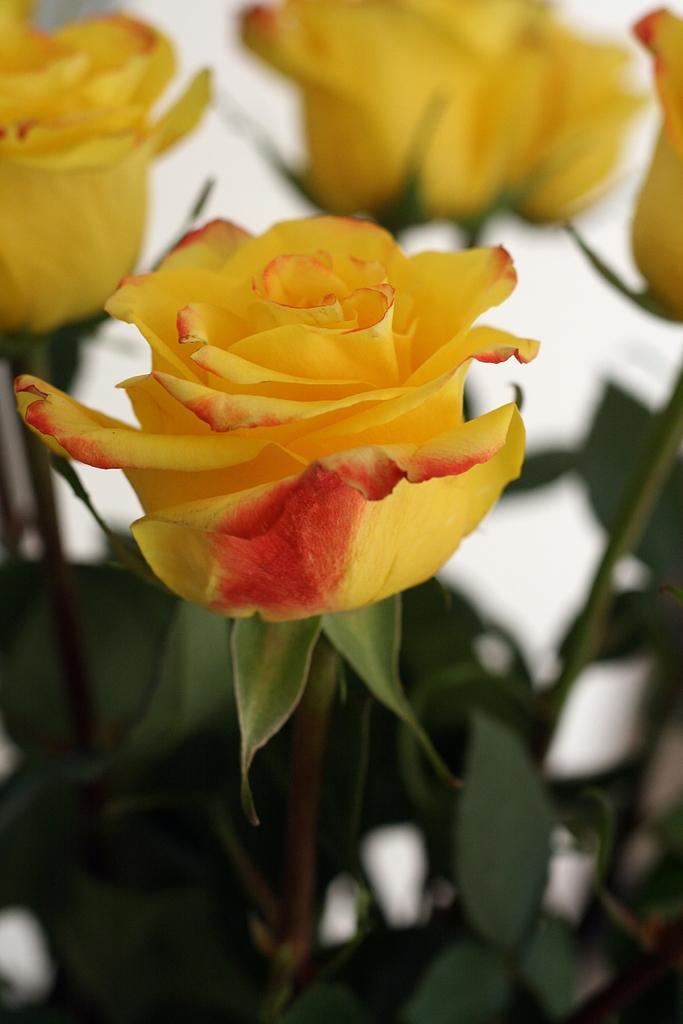Could you give a brief overview of what you see in this image? In this image, we can see roses which are in yellow color and there are leaves. 